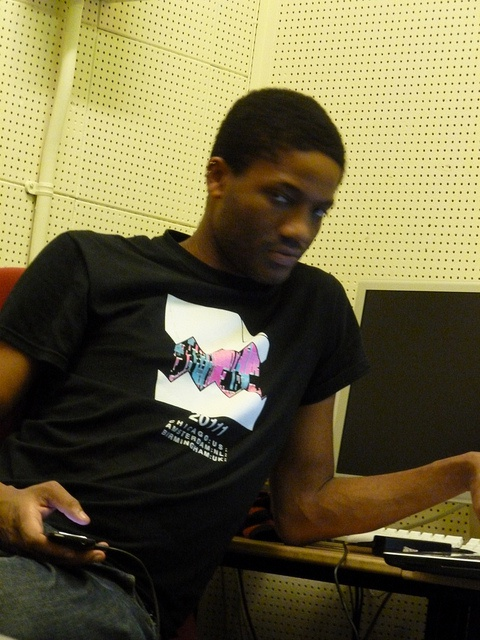Describe the objects in this image and their specific colors. I can see people in khaki, black, maroon, olive, and beige tones, tv in khaki, black, and tan tones, keyboard in khaki, beige, and tan tones, and cell phone in khaki, black, darkgreen, and gray tones in this image. 